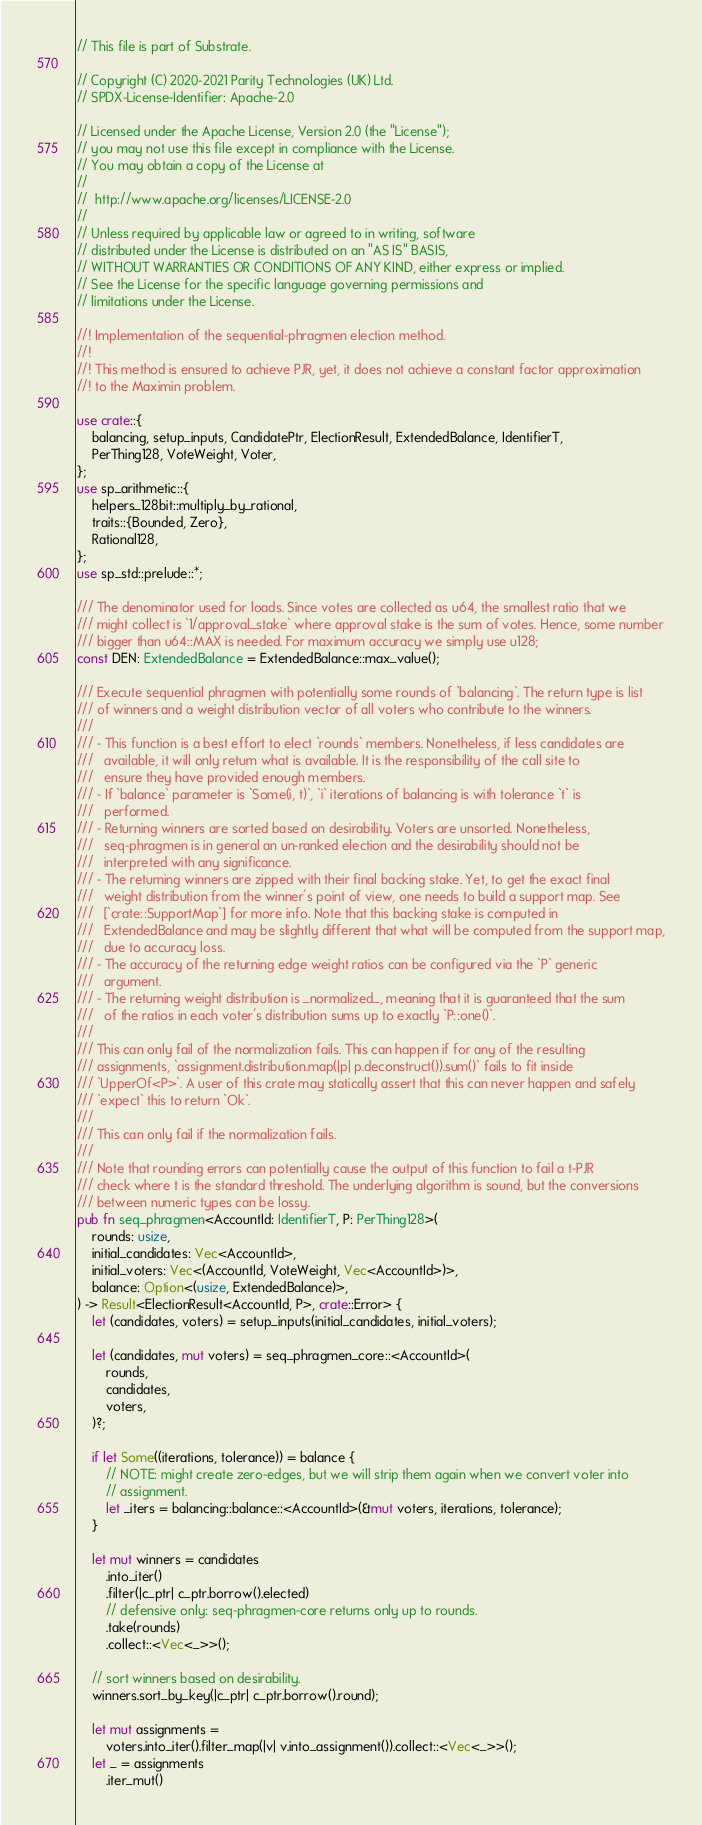Convert code to text. <code><loc_0><loc_0><loc_500><loc_500><_Rust_>// This file is part of Substrate.

// Copyright (C) 2020-2021 Parity Technologies (UK) Ltd.
// SPDX-License-Identifier: Apache-2.0

// Licensed under the Apache License, Version 2.0 (the "License");
// you may not use this file except in compliance with the License.
// You may obtain a copy of the License at
//
// 	http://www.apache.org/licenses/LICENSE-2.0
//
// Unless required by applicable law or agreed to in writing, software
// distributed under the License is distributed on an "AS IS" BASIS,
// WITHOUT WARRANTIES OR CONDITIONS OF ANY KIND, either express or implied.
// See the License for the specific language governing permissions and
// limitations under the License.

//! Implementation of the sequential-phragmen election method.
//!
//! This method is ensured to achieve PJR, yet, it does not achieve a constant factor approximation
//! to the Maximin problem.

use crate::{
	balancing, setup_inputs, CandidatePtr, ElectionResult, ExtendedBalance, IdentifierT,
	PerThing128, VoteWeight, Voter,
};
use sp_arithmetic::{
	helpers_128bit::multiply_by_rational,
	traits::{Bounded, Zero},
	Rational128,
};
use sp_std::prelude::*;

/// The denominator used for loads. Since votes are collected as u64, the smallest ratio that we
/// might collect is `1/approval_stake` where approval stake is the sum of votes. Hence, some number
/// bigger than u64::MAX is needed. For maximum accuracy we simply use u128;
const DEN: ExtendedBalance = ExtendedBalance::max_value();

/// Execute sequential phragmen with potentially some rounds of `balancing`. The return type is list
/// of winners and a weight distribution vector of all voters who contribute to the winners.
///
/// - This function is a best effort to elect `rounds` members. Nonetheless, if less candidates are
///   available, it will only return what is available. It is the responsibility of the call site to
///   ensure they have provided enough members.
/// - If `balance` parameter is `Some(i, t)`, `i` iterations of balancing is with tolerance `t` is
///   performed.
/// - Returning winners are sorted based on desirability. Voters are unsorted. Nonetheless,
///   seq-phragmen is in general an un-ranked election and the desirability should not be
///   interpreted with any significance.
/// - The returning winners are zipped with their final backing stake. Yet, to get the exact final
///   weight distribution from the winner's point of view, one needs to build a support map. See
///   [`crate::SupportMap`] for more info. Note that this backing stake is computed in
///   ExtendedBalance and may be slightly different that what will be computed from the support map,
///   due to accuracy loss.
/// - The accuracy of the returning edge weight ratios can be configured via the `P` generic
///   argument.
/// - The returning weight distribution is _normalized_, meaning that it is guaranteed that the sum
///   of the ratios in each voter's distribution sums up to exactly `P::one()`.
///
/// This can only fail of the normalization fails. This can happen if for any of the resulting
/// assignments, `assignment.distribution.map(|p| p.deconstruct()).sum()` fails to fit inside
/// `UpperOf<P>`. A user of this crate may statically assert that this can never happen and safely
/// `expect` this to return `Ok`.
///
/// This can only fail if the normalization fails.
///
/// Note that rounding errors can potentially cause the output of this function to fail a t-PJR
/// check where t is the standard threshold. The underlying algorithm is sound, but the conversions
/// between numeric types can be lossy.
pub fn seq_phragmen<AccountId: IdentifierT, P: PerThing128>(
	rounds: usize,
	initial_candidates: Vec<AccountId>,
	initial_voters: Vec<(AccountId, VoteWeight, Vec<AccountId>)>,
	balance: Option<(usize, ExtendedBalance)>,
) -> Result<ElectionResult<AccountId, P>, crate::Error> {
	let (candidates, voters) = setup_inputs(initial_candidates, initial_voters);

	let (candidates, mut voters) = seq_phragmen_core::<AccountId>(
		rounds,
		candidates,
		voters,
	)?;

	if let Some((iterations, tolerance)) = balance {
		// NOTE: might create zero-edges, but we will strip them again when we convert voter into
		// assignment.
		let _iters = balancing::balance::<AccountId>(&mut voters, iterations, tolerance);
	}

	let mut winners = candidates
		.into_iter()
		.filter(|c_ptr| c_ptr.borrow().elected)
		// defensive only: seq-phragmen-core returns only up to rounds.
		.take(rounds)
		.collect::<Vec<_>>();

	// sort winners based on desirability.
	winners.sort_by_key(|c_ptr| c_ptr.borrow().round);

	let mut assignments =
		voters.into_iter().filter_map(|v| v.into_assignment()).collect::<Vec<_>>();
	let _ = assignments
		.iter_mut()</code> 